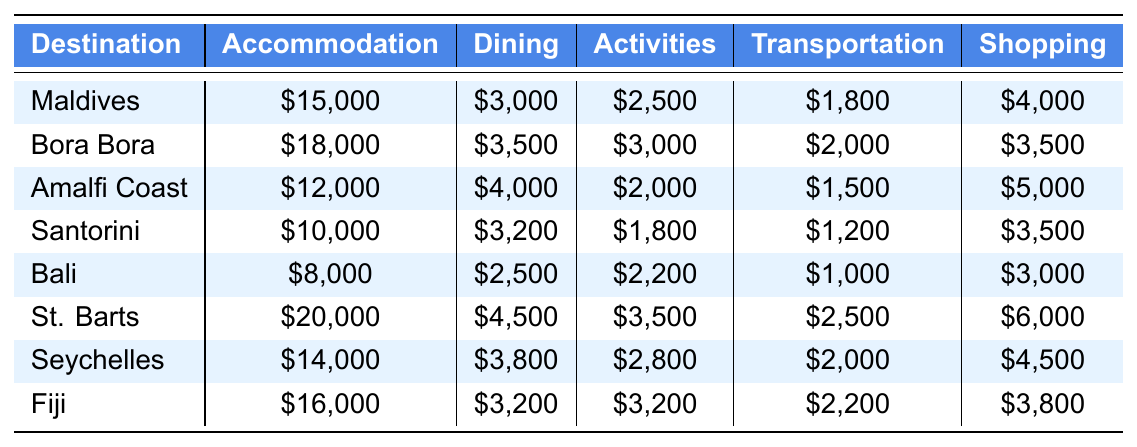What is the most expensive destination for accommodation? Looking at the accommodation values in the table, St. Barts has the highest cost at $20,000.
Answer: St. Barts Which destination has the lowest dining expense? By comparing the dining expenses, Bali has the lowest cost at $2,500.
Answer: Bali How much is spent on activities in Santorini? The table shows that activities in Santorini cost $1,800.
Answer: $1,800 What is the total transportation cost for all listed destinations? Summing up the transportation costs: $1,800 + $2,000 + $1,500 + $1,200 + $1,000 + $2,500 + $2,000 + $2,200 = $14,200.
Answer: $14,200 Is the average shopping expense greater than $4,000? The shopping expenses are: $4,000, $3,500, $5,000, $3,500, $3,000, $6,000, $4,500, and $3,800. The average is calculated as ($4,000 + $3,500 + $5,000 + $3,500 + $3,000 + $6,000 + $4,500 + $3,800) / 8 = $4,125, which is greater than $4,000.
Answer: Yes Which destination has the highest total expenses? Adding the expenses for each destination: Maldives ($15,000 + $3,000 + $2,500 + $1,800 + $4,000 = $26,300), Bora Bora ($18,000 + $3,500 + $3,000 + $2,000 + $3,500 = $30,000), Amalfi Coast ($12,000 + $4,000 + $2,000 + $1,500 + $5,000 = $24,500), Santorini ($10,000 + $3,200 + $1,800 + $1,200 + $3,500 = $19,700), Bali ($8,000 + $2,500 + $2,200 + $1,000 + $3,000 = $16,700), St. Barts ($20,000 + $4,500 + $3,500 + $2,500 + $6,000 = $36,500), Seychelles ($14,000 + $3,800 + $2,800 + $2,000 + $4,500 = $27,100), Fiji ($16,000 + $3,200 + $3,200 + $2,200 + $3,800 = $28,400). Therefore, St. Barts has the highest total expenses of $36,500.
Answer: St. Barts What is the difference in shopping expenses between Bora Bora and the Amalfi Coast? Bora Bora's shopping expense is $3,500 and Amalfi Coast's is $5,000. The difference is $5,000 - $3,500 = $1,500.
Answer: $1,500 